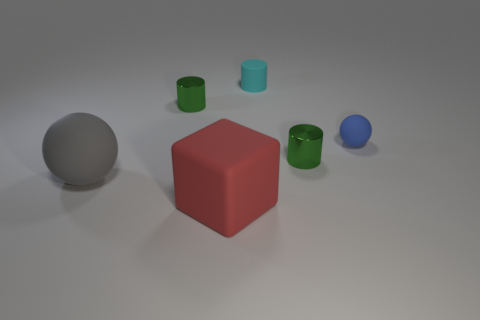Are there the same number of big matte objects that are behind the cyan rubber thing and big red matte objects behind the large red object?
Offer a terse response. Yes. There is a gray rubber thing; does it have the same size as the sphere that is on the right side of the large red thing?
Offer a very short reply. No. Are there more green things behind the tiny blue ball than big cyan cylinders?
Ensure brevity in your answer.  Yes. How many matte blocks have the same size as the gray object?
Your answer should be compact. 1. There is a ball that is to the right of the tiny cyan rubber object; does it have the same size as the object in front of the big ball?
Provide a short and direct response. No. Is the number of blue matte objects that are behind the large rubber ball greater than the number of green shiny cylinders behind the cyan matte object?
Keep it short and to the point. Yes. How many other matte things are the same shape as the gray thing?
Keep it short and to the point. 1. Is there a small cyan object made of the same material as the blue thing?
Offer a very short reply. Yes. Is the number of gray objects that are to the left of the large red object less than the number of cyan rubber cylinders?
Your answer should be compact. No. What material is the sphere that is on the right side of the metal object behind the small blue rubber ball?
Offer a very short reply. Rubber. 